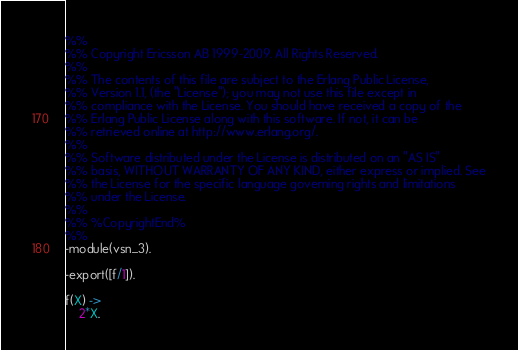<code> <loc_0><loc_0><loc_500><loc_500><_Erlang_>%% 
%% Copyright Ericsson AB 1999-2009. All Rights Reserved.
%% 
%% The contents of this file are subject to the Erlang Public License,
%% Version 1.1, (the "License"); you may not use this file except in
%% compliance with the License. You should have received a copy of the
%% Erlang Public License along with this software. If not, it can be
%% retrieved online at http://www.erlang.org/.
%% 
%% Software distributed under the License is distributed on an "AS IS"
%% basis, WITHOUT WARRANTY OF ANY KIND, either express or implied. See
%% the License for the specific language governing rights and limitations
%% under the License.
%% 
%% %CopyrightEnd%
%%
-module(vsn_3).

-export([f/1]).

f(X) ->
    2*X.
</code> 